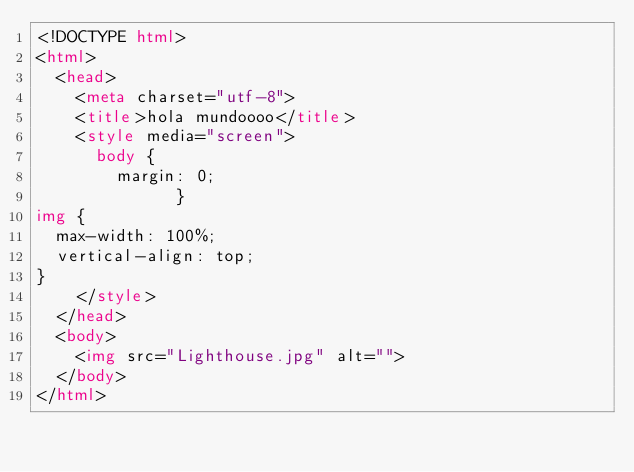Convert code to text. <code><loc_0><loc_0><loc_500><loc_500><_HTML_><!DOCTYPE html>
<html>
  <head>
    <meta charset="utf-8">
    <title>hola mundoooo</title>
    <style media="screen">
      body {
        margin: 0;
              }
img {
  max-width: 100%;
  vertical-align: top;
}
    </style>
  </head>
  <body>
    <img src="Lighthouse.jpg" alt="">
  </body>
</html>
</code> 